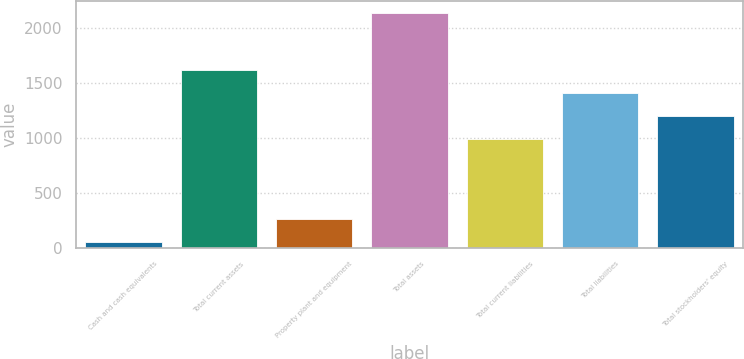Convert chart to OTSL. <chart><loc_0><loc_0><loc_500><loc_500><bar_chart><fcel>Cash and cash equivalents<fcel>Total current assets<fcel>Property plant and equipment<fcel>Total assets<fcel>Total current liabilities<fcel>Total liabilities<fcel>Total stockholders' equity<nl><fcel>50.1<fcel>1615.68<fcel>258.56<fcel>2134.7<fcel>990.3<fcel>1407.22<fcel>1198.76<nl></chart> 